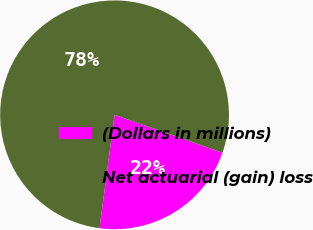Convert chart to OTSL. <chart><loc_0><loc_0><loc_500><loc_500><pie_chart><fcel>(Dollars in millions)<fcel>Net actuarial (gain) loss<nl><fcel>21.73%<fcel>78.27%<nl></chart> 